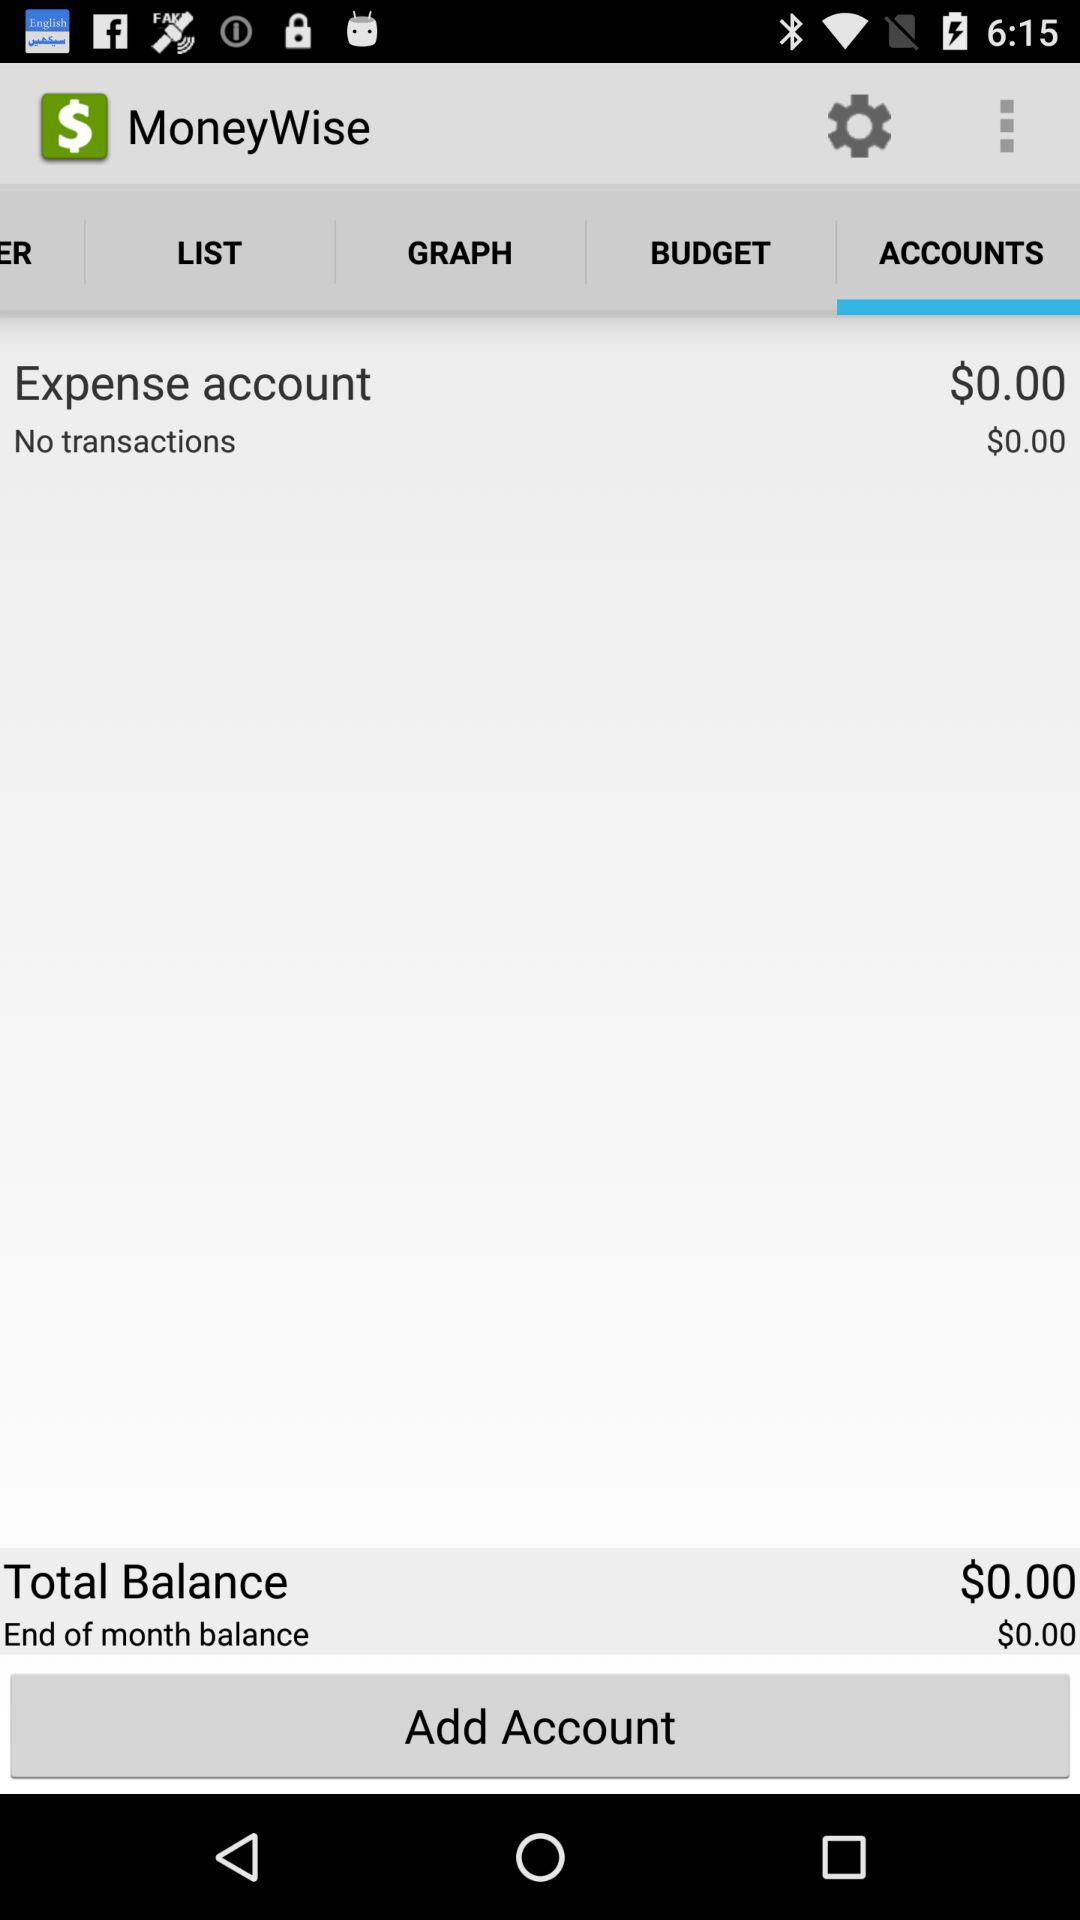What is the end of month balance? The end of month balance is $0.00. 